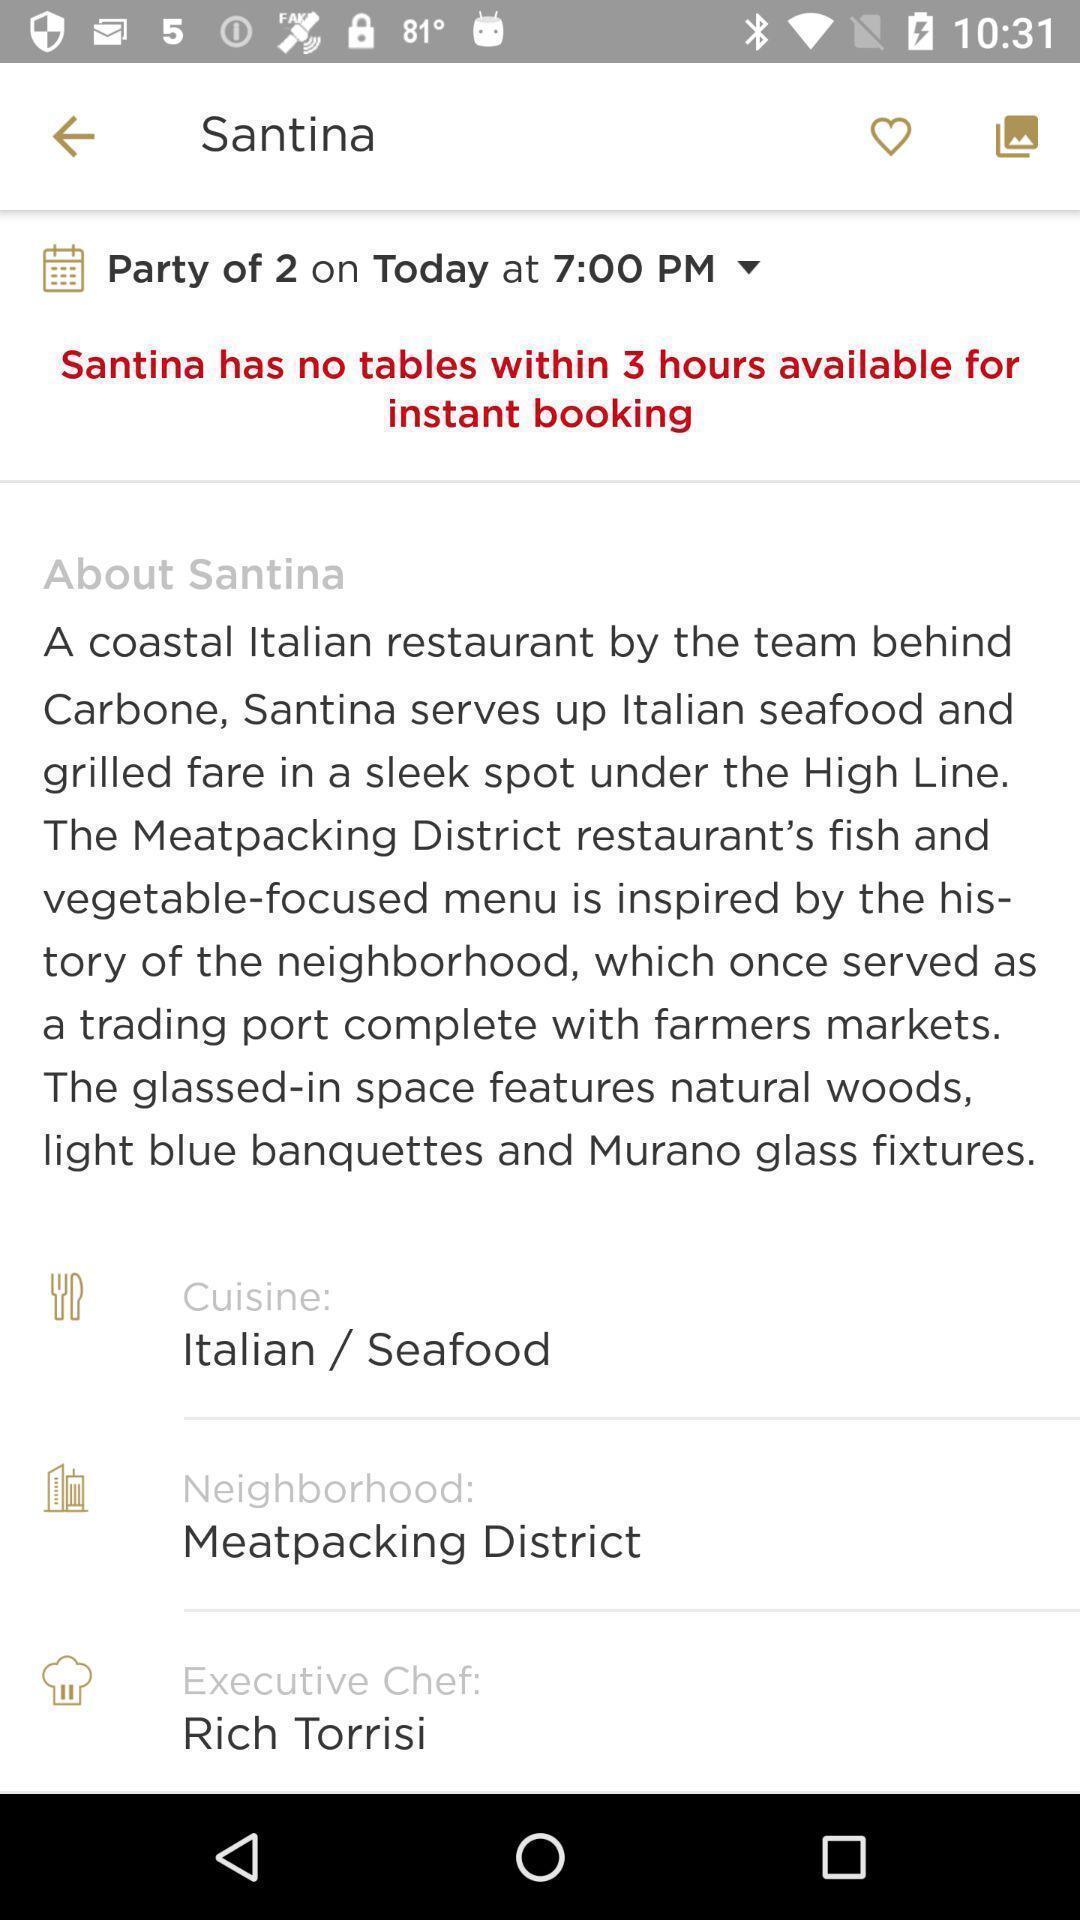Describe the content in this image. Santina has no tables in instant booking. 